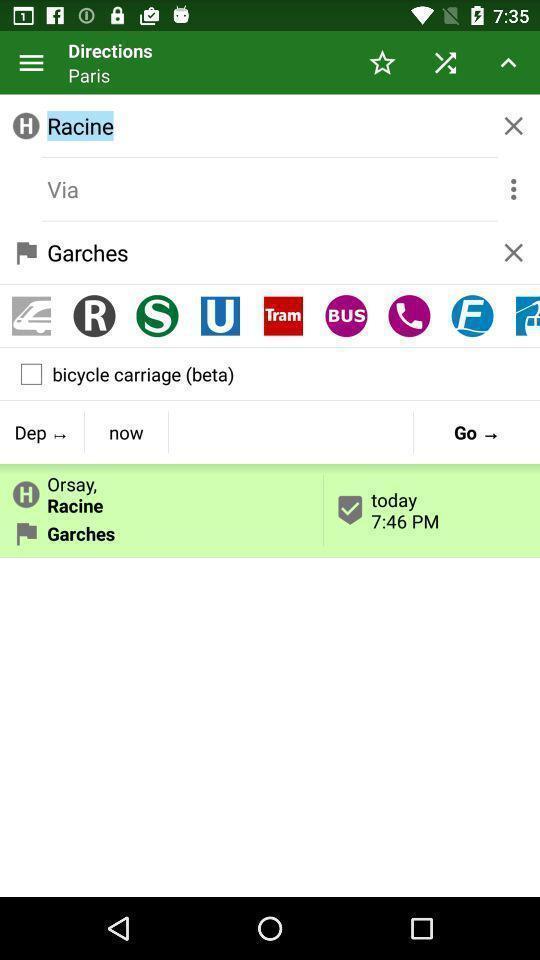What details can you identify in this image? Page displays apps regarding routes. 